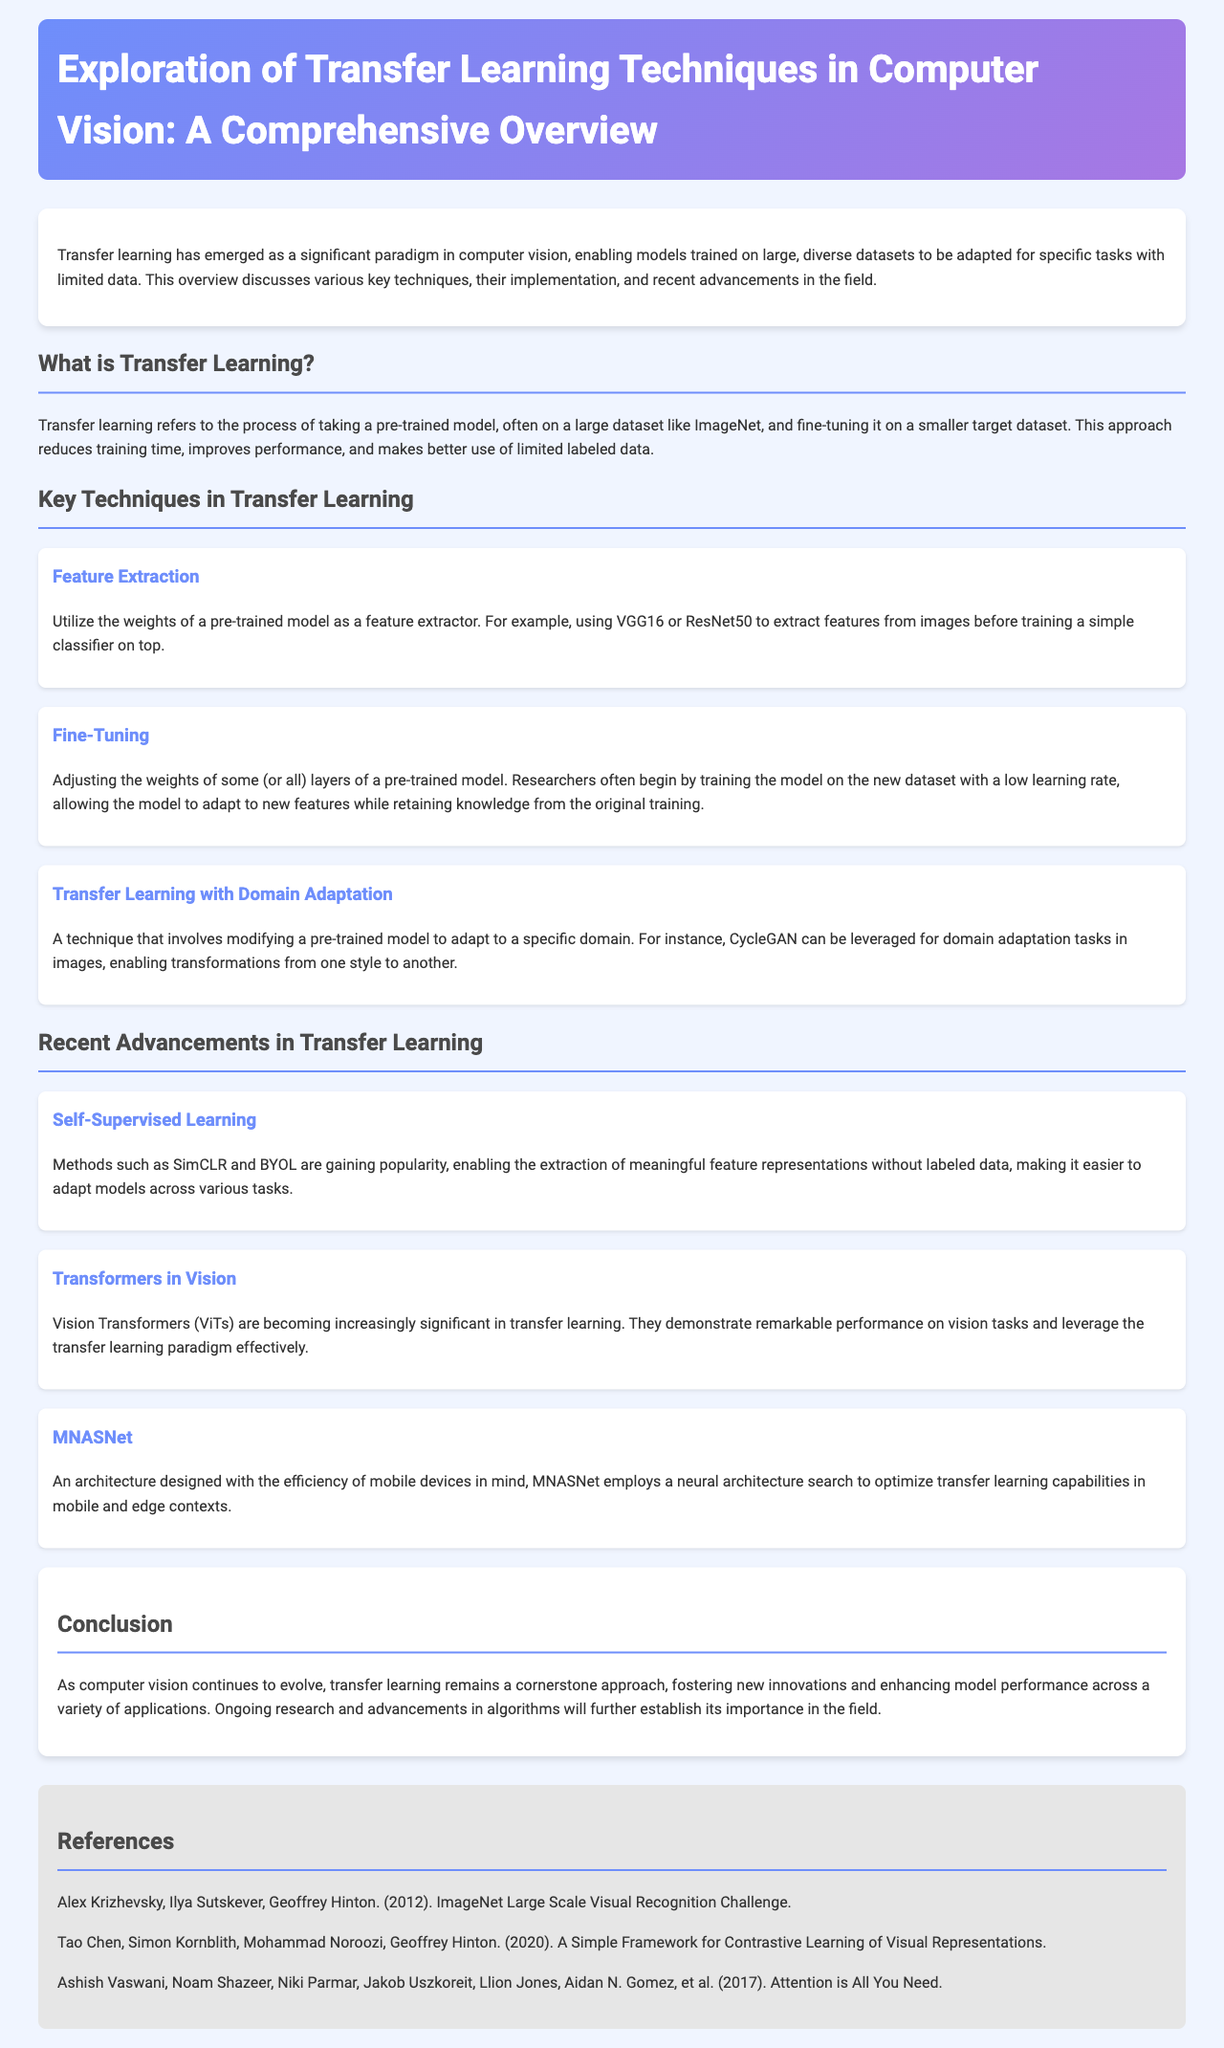What is the title of the document? The title of the document is provided in the header section, which introduces the main topic being discussed.
Answer: Exploration of Transfer Learning Techniques in Computer Vision: A Comprehensive Overview What does transfer learning enable? The introduction section describes the capability of transfer learning to adapt models trained on large datasets for specific tasks with limited data.
Answer: Adaptation for specific tasks What is one key technique in transfer learning mentioned? The section on key techniques lists specific methods used in transfer learning.
Answer: Feature Extraction What is the name of a recent advancement in transfer learning? The section on recent advancements highlights new developments within the field of transfer learning.
Answer: Self-Supervised Learning Who are the authors of the 2012 ImageNet paper? The references section contains the citation for the ImageNet paper along with its authors.
Answer: Alex Krizhevsky, Ilya Sutskever, Geoffrey Hinton What does the Fine-Tuning technique adjust? The description of Fine-Tuning specifies what part of the pre-trained model is modified during the transfer learning process.
Answer: Weights of some (or all) layers What did Vision Transformers demonstrate? The advancements section mentions the effectiveness of a specific architecture in transfer learning and its performance.
Answer: Remarkable performance on vision tasks How is MNASNet described in relation to mobile devices? The summary of MNASNet provides insight into its design purpose and context of use.
Answer: Efficiency of mobile devices 